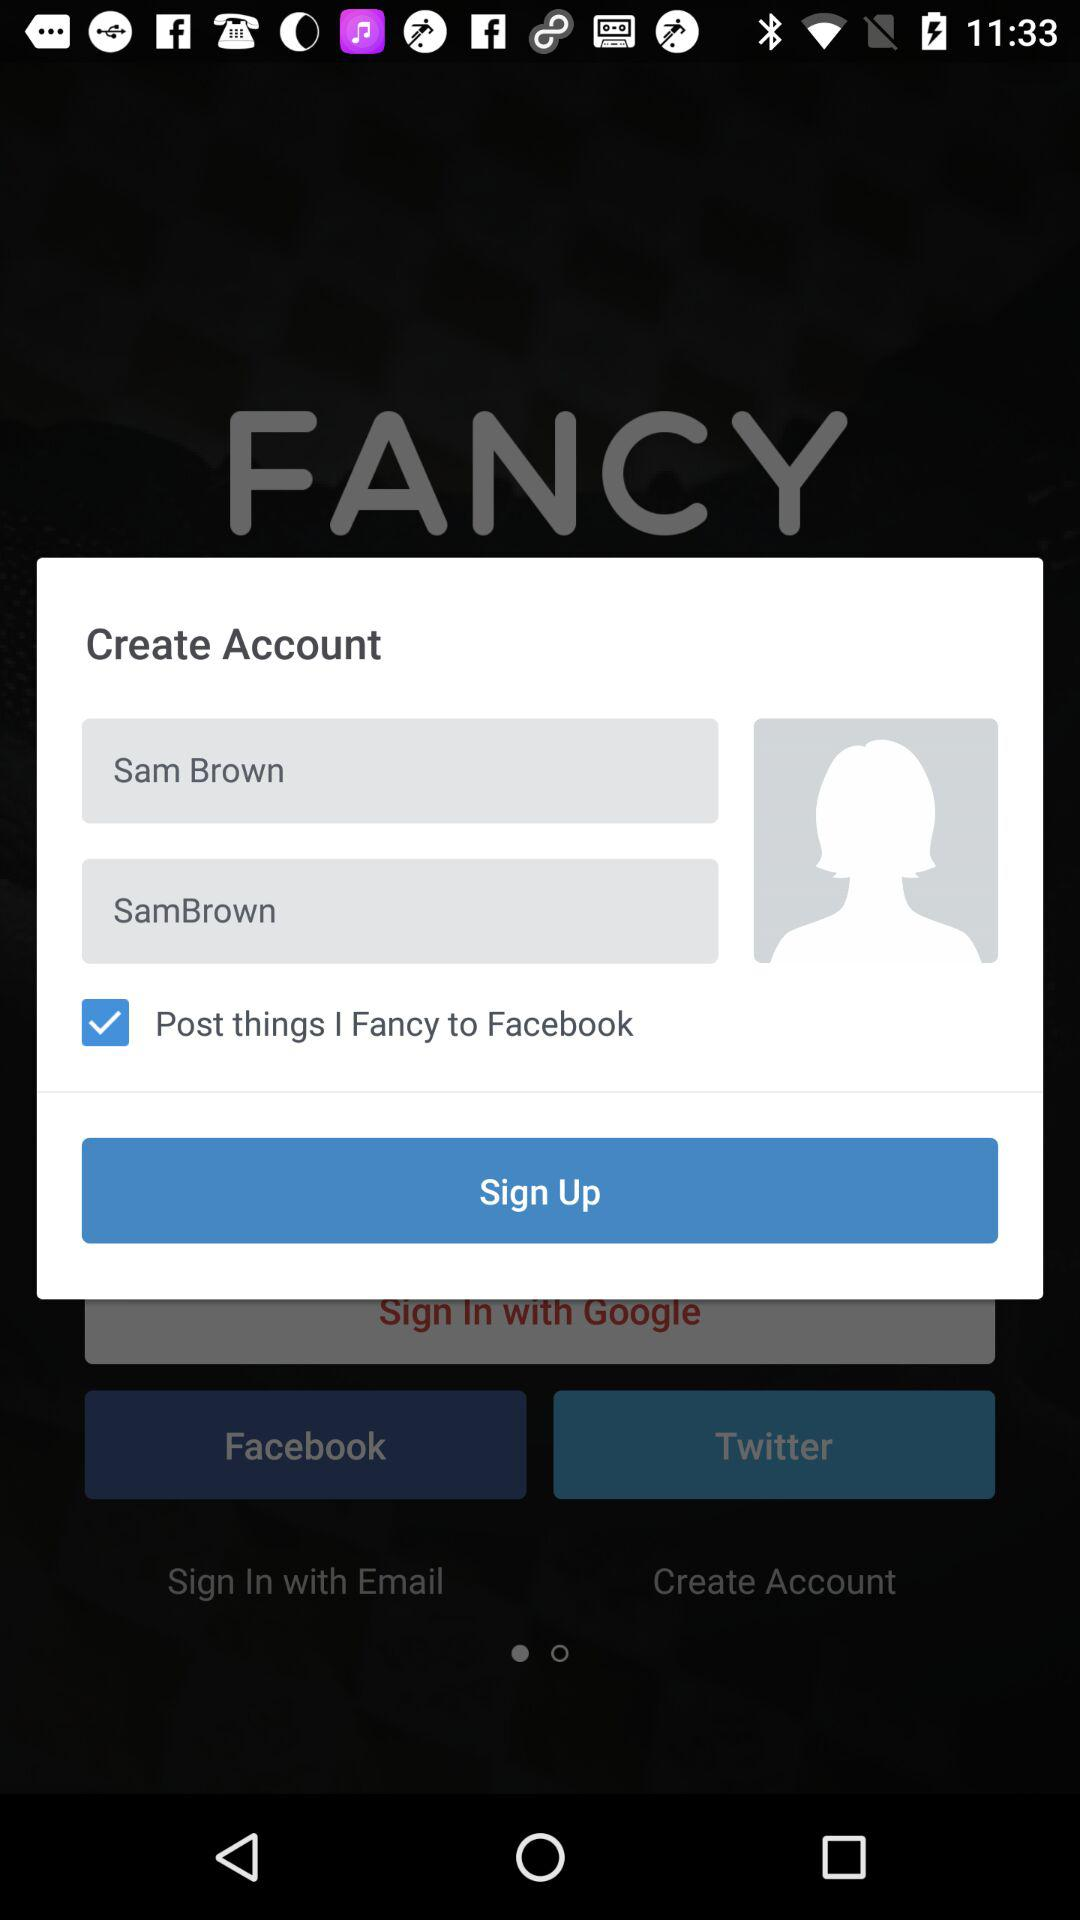What is the status of "Post things"? The status is "on". 